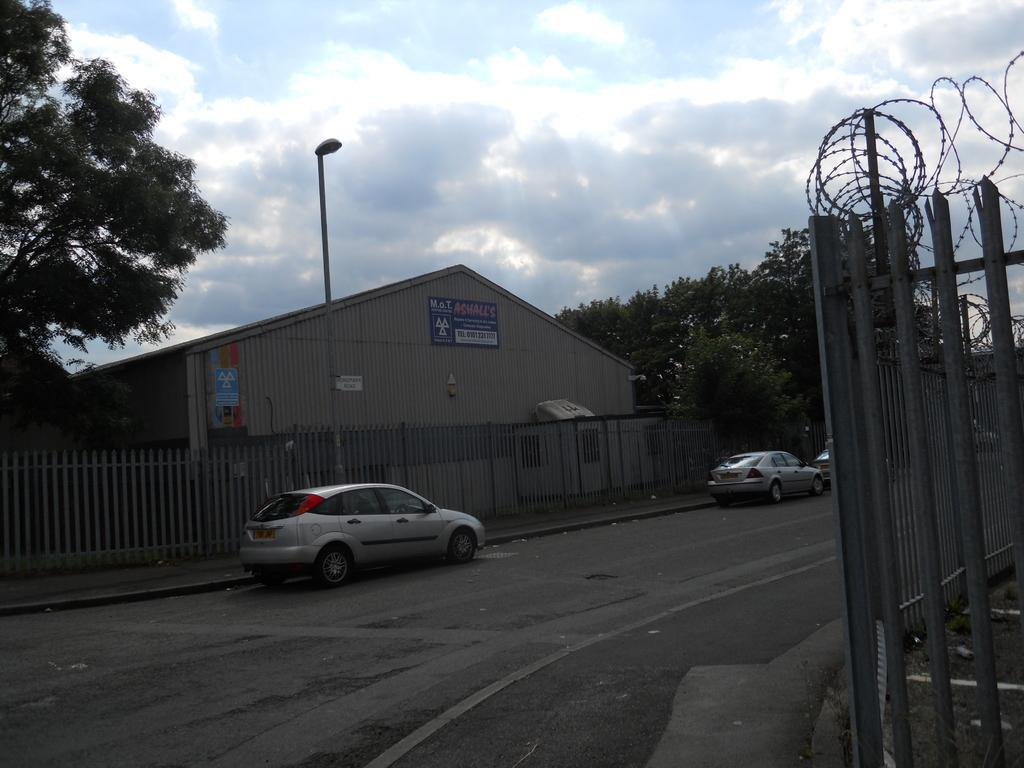What type of structure is present in the image? There is a house in the image. What can be seen surrounding the house? There is a fence in the image. What type of vehicles are visible in the image? There are cars in the image. What type of vegetation is present in the image? There are trees in the image. What type of lighting fixture is present in the image? There is a street lamp in the image. What is visible in the sky in the image? The sky is visible in the image, and there are clouds in the sky. How many ladybugs are crawling on the cars in the image? There are no ladybugs present in the image; only cars, a house, a fence, trees, a street lamp, and the sky are visible. 